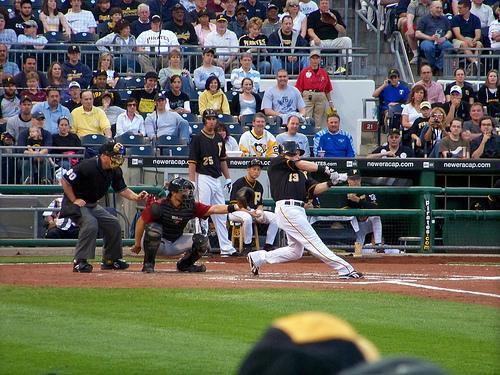How many catchers are in the picture?
Give a very brief answer. 1. 